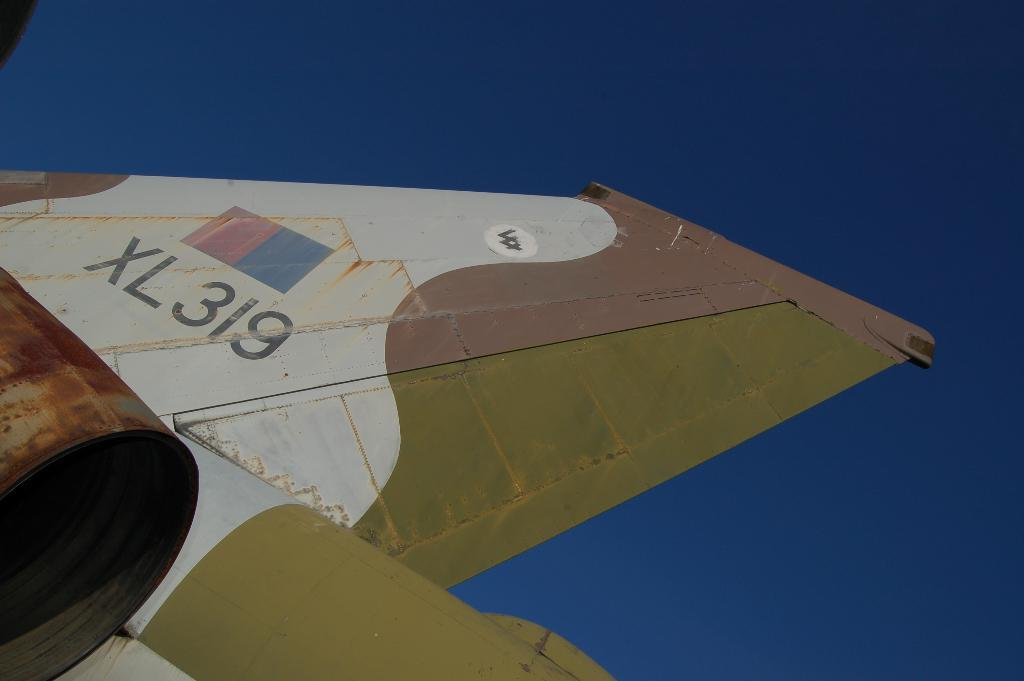<image>
Create a compact narrative representing the image presented. The tail of the plane here has the number XL 319 on it 